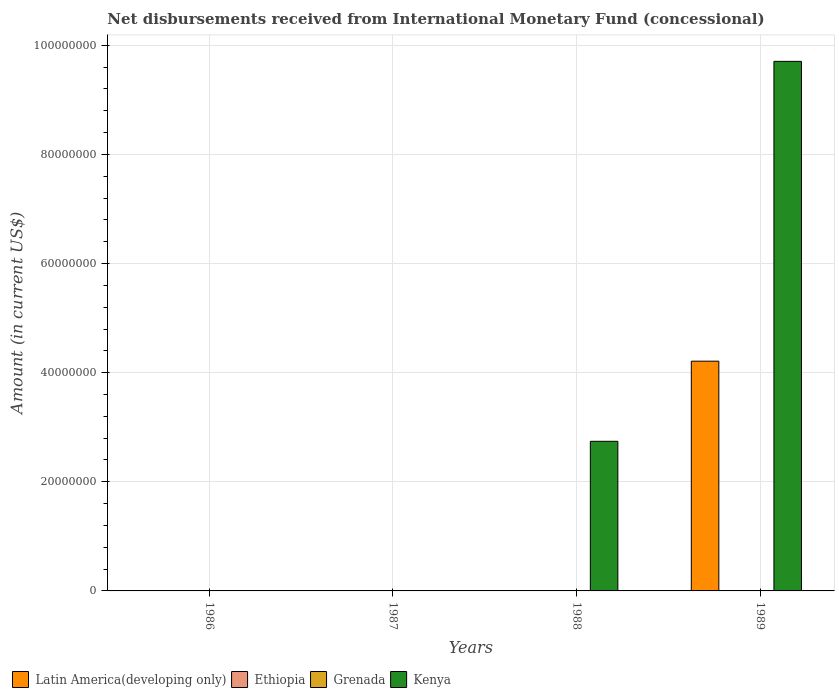How many different coloured bars are there?
Your answer should be very brief. 2. Are the number of bars per tick equal to the number of legend labels?
Keep it short and to the point. No. Are the number of bars on each tick of the X-axis equal?
Your response must be concise. No. How many bars are there on the 3rd tick from the left?
Your answer should be very brief. 1. In how many cases, is the number of bars for a given year not equal to the number of legend labels?
Your answer should be compact. 4. What is the amount of disbursements received from International Monetary Fund in Latin America(developing only) in 1989?
Make the answer very short. 4.21e+07. Across all years, what is the maximum amount of disbursements received from International Monetary Fund in Latin America(developing only)?
Keep it short and to the point. 4.21e+07. Across all years, what is the minimum amount of disbursements received from International Monetary Fund in Latin America(developing only)?
Offer a very short reply. 0. In which year was the amount of disbursements received from International Monetary Fund in Latin America(developing only) maximum?
Offer a very short reply. 1989. What is the total amount of disbursements received from International Monetary Fund in Ethiopia in the graph?
Make the answer very short. 0. What is the difference between the amount of disbursements received from International Monetary Fund in Kenya in 1988 and that in 1989?
Your response must be concise. -6.96e+07. What is the difference between the amount of disbursements received from International Monetary Fund in Grenada in 1986 and the amount of disbursements received from International Monetary Fund in Ethiopia in 1987?
Ensure brevity in your answer.  0. What is the average amount of disbursements received from International Monetary Fund in Kenya per year?
Make the answer very short. 3.11e+07. In how many years, is the amount of disbursements received from International Monetary Fund in Kenya greater than 52000000 US$?
Provide a short and direct response. 1. Is the amount of disbursements received from International Monetary Fund in Kenya in 1988 less than that in 1989?
Your answer should be compact. Yes. What is the difference between the highest and the lowest amount of disbursements received from International Monetary Fund in Kenya?
Ensure brevity in your answer.  9.71e+07. Is it the case that in every year, the sum of the amount of disbursements received from International Monetary Fund in Ethiopia and amount of disbursements received from International Monetary Fund in Grenada is greater than the sum of amount of disbursements received from International Monetary Fund in Kenya and amount of disbursements received from International Monetary Fund in Latin America(developing only)?
Provide a short and direct response. No. Is it the case that in every year, the sum of the amount of disbursements received from International Monetary Fund in Latin America(developing only) and amount of disbursements received from International Monetary Fund in Ethiopia is greater than the amount of disbursements received from International Monetary Fund in Grenada?
Provide a succinct answer. No. How many bars are there?
Offer a very short reply. 3. Are all the bars in the graph horizontal?
Provide a short and direct response. No. Are the values on the major ticks of Y-axis written in scientific E-notation?
Make the answer very short. No. Where does the legend appear in the graph?
Provide a short and direct response. Bottom left. How are the legend labels stacked?
Provide a short and direct response. Horizontal. What is the title of the graph?
Provide a succinct answer. Net disbursements received from International Monetary Fund (concessional). Does "Bolivia" appear as one of the legend labels in the graph?
Your response must be concise. No. What is the label or title of the Y-axis?
Offer a terse response. Amount (in current US$). What is the Amount (in current US$) in Grenada in 1986?
Your answer should be compact. 0. What is the Amount (in current US$) of Latin America(developing only) in 1987?
Keep it short and to the point. 0. What is the Amount (in current US$) of Ethiopia in 1987?
Offer a very short reply. 0. What is the Amount (in current US$) of Grenada in 1987?
Your answer should be very brief. 0. What is the Amount (in current US$) in Latin America(developing only) in 1988?
Keep it short and to the point. 0. What is the Amount (in current US$) of Ethiopia in 1988?
Ensure brevity in your answer.  0. What is the Amount (in current US$) of Kenya in 1988?
Your answer should be very brief. 2.74e+07. What is the Amount (in current US$) in Latin America(developing only) in 1989?
Your answer should be very brief. 4.21e+07. What is the Amount (in current US$) of Ethiopia in 1989?
Give a very brief answer. 0. What is the Amount (in current US$) of Kenya in 1989?
Your answer should be very brief. 9.71e+07. Across all years, what is the maximum Amount (in current US$) in Latin America(developing only)?
Make the answer very short. 4.21e+07. Across all years, what is the maximum Amount (in current US$) in Kenya?
Provide a succinct answer. 9.71e+07. Across all years, what is the minimum Amount (in current US$) of Latin America(developing only)?
Your response must be concise. 0. Across all years, what is the minimum Amount (in current US$) in Kenya?
Provide a short and direct response. 0. What is the total Amount (in current US$) in Latin America(developing only) in the graph?
Make the answer very short. 4.21e+07. What is the total Amount (in current US$) of Ethiopia in the graph?
Ensure brevity in your answer.  0. What is the total Amount (in current US$) of Kenya in the graph?
Provide a succinct answer. 1.24e+08. What is the difference between the Amount (in current US$) of Kenya in 1988 and that in 1989?
Keep it short and to the point. -6.96e+07. What is the average Amount (in current US$) in Latin America(developing only) per year?
Your response must be concise. 1.05e+07. What is the average Amount (in current US$) in Kenya per year?
Keep it short and to the point. 3.11e+07. In the year 1989, what is the difference between the Amount (in current US$) in Latin America(developing only) and Amount (in current US$) in Kenya?
Your answer should be very brief. -5.50e+07. What is the ratio of the Amount (in current US$) in Kenya in 1988 to that in 1989?
Give a very brief answer. 0.28. What is the difference between the highest and the lowest Amount (in current US$) of Latin America(developing only)?
Make the answer very short. 4.21e+07. What is the difference between the highest and the lowest Amount (in current US$) in Kenya?
Give a very brief answer. 9.71e+07. 